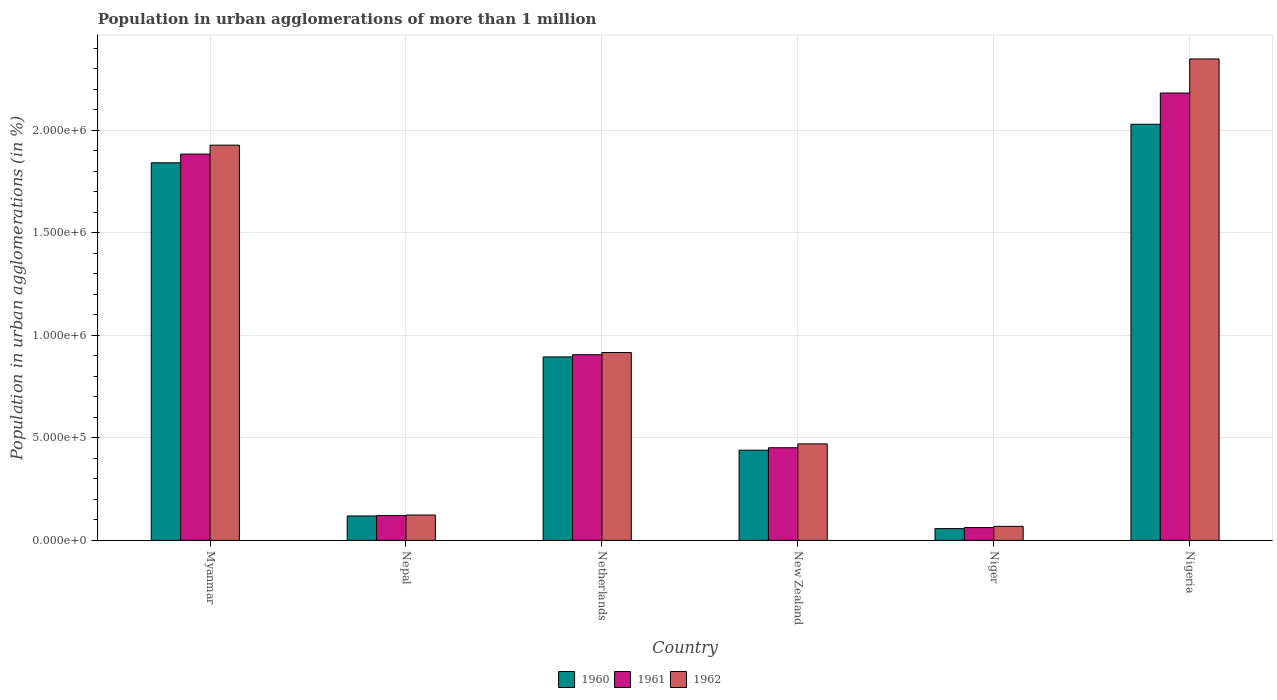How many different coloured bars are there?
Ensure brevity in your answer.  3. How many groups of bars are there?
Your answer should be very brief. 6. Are the number of bars per tick equal to the number of legend labels?
Your answer should be compact. Yes. How many bars are there on the 4th tick from the left?
Ensure brevity in your answer.  3. How many bars are there on the 6th tick from the right?
Offer a very short reply. 3. What is the label of the 6th group of bars from the left?
Provide a short and direct response. Nigeria. What is the population in urban agglomerations in 1961 in Netherlands?
Your answer should be compact. 9.06e+05. Across all countries, what is the maximum population in urban agglomerations in 1962?
Ensure brevity in your answer.  2.35e+06. Across all countries, what is the minimum population in urban agglomerations in 1960?
Give a very brief answer. 5.75e+04. In which country was the population in urban agglomerations in 1962 maximum?
Make the answer very short. Nigeria. In which country was the population in urban agglomerations in 1962 minimum?
Your answer should be compact. Niger. What is the total population in urban agglomerations in 1960 in the graph?
Your answer should be compact. 5.38e+06. What is the difference between the population in urban agglomerations in 1961 in Nepal and that in Niger?
Keep it short and to the point. 5.84e+04. What is the difference between the population in urban agglomerations in 1962 in Nigeria and the population in urban agglomerations in 1961 in Nepal?
Your answer should be very brief. 2.23e+06. What is the average population in urban agglomerations in 1960 per country?
Offer a terse response. 8.97e+05. What is the difference between the population in urban agglomerations of/in 1961 and population in urban agglomerations of/in 1962 in Myanmar?
Your response must be concise. -4.36e+04. What is the ratio of the population in urban agglomerations in 1962 in New Zealand to that in Niger?
Make the answer very short. 6.89. Is the population in urban agglomerations in 1960 in Nepal less than that in Nigeria?
Offer a terse response. Yes. What is the difference between the highest and the second highest population in urban agglomerations in 1962?
Keep it short and to the point. -1.43e+06. What is the difference between the highest and the lowest population in urban agglomerations in 1962?
Your response must be concise. 2.28e+06. How many bars are there?
Offer a very short reply. 18. Are all the bars in the graph horizontal?
Your answer should be very brief. No. Does the graph contain grids?
Ensure brevity in your answer.  Yes. Where does the legend appear in the graph?
Your response must be concise. Bottom center. How many legend labels are there?
Your response must be concise. 3. How are the legend labels stacked?
Make the answer very short. Horizontal. What is the title of the graph?
Ensure brevity in your answer.  Population in urban agglomerations of more than 1 million. Does "1998" appear as one of the legend labels in the graph?
Your answer should be very brief. No. What is the label or title of the Y-axis?
Your answer should be compact. Population in urban agglomerations (in %). What is the Population in urban agglomerations (in %) of 1960 in Myanmar?
Offer a terse response. 1.84e+06. What is the Population in urban agglomerations (in %) of 1961 in Myanmar?
Provide a short and direct response. 1.88e+06. What is the Population in urban agglomerations (in %) of 1962 in Myanmar?
Provide a short and direct response. 1.93e+06. What is the Population in urban agglomerations (in %) of 1960 in Nepal?
Give a very brief answer. 1.19e+05. What is the Population in urban agglomerations (in %) in 1961 in Nepal?
Your answer should be compact. 1.21e+05. What is the Population in urban agglomerations (in %) of 1962 in Nepal?
Offer a terse response. 1.24e+05. What is the Population in urban agglomerations (in %) in 1960 in Netherlands?
Offer a terse response. 8.95e+05. What is the Population in urban agglomerations (in %) of 1961 in Netherlands?
Provide a succinct answer. 9.06e+05. What is the Population in urban agglomerations (in %) in 1962 in Netherlands?
Your answer should be very brief. 9.17e+05. What is the Population in urban agglomerations (in %) in 1960 in New Zealand?
Ensure brevity in your answer.  4.40e+05. What is the Population in urban agglomerations (in %) in 1961 in New Zealand?
Offer a very short reply. 4.52e+05. What is the Population in urban agglomerations (in %) of 1962 in New Zealand?
Provide a succinct answer. 4.71e+05. What is the Population in urban agglomerations (in %) in 1960 in Niger?
Your response must be concise. 5.75e+04. What is the Population in urban agglomerations (in %) in 1961 in Niger?
Provide a succinct answer. 6.27e+04. What is the Population in urban agglomerations (in %) in 1962 in Niger?
Give a very brief answer. 6.83e+04. What is the Population in urban agglomerations (in %) of 1960 in Nigeria?
Your answer should be very brief. 2.03e+06. What is the Population in urban agglomerations (in %) in 1961 in Nigeria?
Your answer should be very brief. 2.18e+06. What is the Population in urban agglomerations (in %) in 1962 in Nigeria?
Your answer should be compact. 2.35e+06. Across all countries, what is the maximum Population in urban agglomerations (in %) of 1960?
Give a very brief answer. 2.03e+06. Across all countries, what is the maximum Population in urban agglomerations (in %) in 1961?
Make the answer very short. 2.18e+06. Across all countries, what is the maximum Population in urban agglomerations (in %) of 1962?
Make the answer very short. 2.35e+06. Across all countries, what is the minimum Population in urban agglomerations (in %) in 1960?
Keep it short and to the point. 5.75e+04. Across all countries, what is the minimum Population in urban agglomerations (in %) in 1961?
Ensure brevity in your answer.  6.27e+04. Across all countries, what is the minimum Population in urban agglomerations (in %) in 1962?
Provide a succinct answer. 6.83e+04. What is the total Population in urban agglomerations (in %) in 1960 in the graph?
Make the answer very short. 5.38e+06. What is the total Population in urban agglomerations (in %) of 1961 in the graph?
Provide a short and direct response. 5.61e+06. What is the total Population in urban agglomerations (in %) in 1962 in the graph?
Provide a short and direct response. 5.86e+06. What is the difference between the Population in urban agglomerations (in %) in 1960 in Myanmar and that in Nepal?
Keep it short and to the point. 1.72e+06. What is the difference between the Population in urban agglomerations (in %) of 1961 in Myanmar and that in Nepal?
Your answer should be compact. 1.76e+06. What is the difference between the Population in urban agglomerations (in %) of 1962 in Myanmar and that in Nepal?
Your answer should be very brief. 1.80e+06. What is the difference between the Population in urban agglomerations (in %) of 1960 in Myanmar and that in Netherlands?
Provide a succinct answer. 9.47e+05. What is the difference between the Population in urban agglomerations (in %) of 1961 in Myanmar and that in Netherlands?
Give a very brief answer. 9.79e+05. What is the difference between the Population in urban agglomerations (in %) in 1962 in Myanmar and that in Netherlands?
Your answer should be compact. 1.01e+06. What is the difference between the Population in urban agglomerations (in %) of 1960 in Myanmar and that in New Zealand?
Offer a very short reply. 1.40e+06. What is the difference between the Population in urban agglomerations (in %) of 1961 in Myanmar and that in New Zealand?
Offer a terse response. 1.43e+06. What is the difference between the Population in urban agglomerations (in %) in 1962 in Myanmar and that in New Zealand?
Give a very brief answer. 1.46e+06. What is the difference between the Population in urban agglomerations (in %) in 1960 in Myanmar and that in Niger?
Provide a succinct answer. 1.78e+06. What is the difference between the Population in urban agglomerations (in %) in 1961 in Myanmar and that in Niger?
Make the answer very short. 1.82e+06. What is the difference between the Population in urban agglomerations (in %) of 1962 in Myanmar and that in Niger?
Your response must be concise. 1.86e+06. What is the difference between the Population in urban agglomerations (in %) of 1960 in Myanmar and that in Nigeria?
Offer a very short reply. -1.88e+05. What is the difference between the Population in urban agglomerations (in %) in 1961 in Myanmar and that in Nigeria?
Provide a short and direct response. -2.98e+05. What is the difference between the Population in urban agglomerations (in %) of 1962 in Myanmar and that in Nigeria?
Your answer should be compact. -4.21e+05. What is the difference between the Population in urban agglomerations (in %) in 1960 in Nepal and that in Netherlands?
Offer a terse response. -7.76e+05. What is the difference between the Population in urban agglomerations (in %) in 1961 in Nepal and that in Netherlands?
Make the answer very short. -7.85e+05. What is the difference between the Population in urban agglomerations (in %) of 1962 in Nepal and that in Netherlands?
Make the answer very short. -7.93e+05. What is the difference between the Population in urban agglomerations (in %) of 1960 in Nepal and that in New Zealand?
Ensure brevity in your answer.  -3.21e+05. What is the difference between the Population in urban agglomerations (in %) in 1961 in Nepal and that in New Zealand?
Your answer should be compact. -3.31e+05. What is the difference between the Population in urban agglomerations (in %) in 1962 in Nepal and that in New Zealand?
Provide a succinct answer. -3.47e+05. What is the difference between the Population in urban agglomerations (in %) of 1960 in Nepal and that in Niger?
Make the answer very short. 6.16e+04. What is the difference between the Population in urban agglomerations (in %) in 1961 in Nepal and that in Niger?
Give a very brief answer. 5.84e+04. What is the difference between the Population in urban agglomerations (in %) of 1962 in Nepal and that in Niger?
Offer a very short reply. 5.54e+04. What is the difference between the Population in urban agglomerations (in %) in 1960 in Nepal and that in Nigeria?
Give a very brief answer. -1.91e+06. What is the difference between the Population in urban agglomerations (in %) of 1961 in Nepal and that in Nigeria?
Provide a short and direct response. -2.06e+06. What is the difference between the Population in urban agglomerations (in %) of 1962 in Nepal and that in Nigeria?
Provide a succinct answer. -2.23e+06. What is the difference between the Population in urban agglomerations (in %) of 1960 in Netherlands and that in New Zealand?
Offer a terse response. 4.55e+05. What is the difference between the Population in urban agglomerations (in %) of 1961 in Netherlands and that in New Zealand?
Give a very brief answer. 4.54e+05. What is the difference between the Population in urban agglomerations (in %) of 1962 in Netherlands and that in New Zealand?
Provide a short and direct response. 4.46e+05. What is the difference between the Population in urban agglomerations (in %) of 1960 in Netherlands and that in Niger?
Make the answer very short. 8.38e+05. What is the difference between the Population in urban agglomerations (in %) in 1961 in Netherlands and that in Niger?
Your response must be concise. 8.43e+05. What is the difference between the Population in urban agglomerations (in %) in 1962 in Netherlands and that in Niger?
Ensure brevity in your answer.  8.48e+05. What is the difference between the Population in urban agglomerations (in %) of 1960 in Netherlands and that in Nigeria?
Offer a terse response. -1.14e+06. What is the difference between the Population in urban agglomerations (in %) of 1961 in Netherlands and that in Nigeria?
Ensure brevity in your answer.  -1.28e+06. What is the difference between the Population in urban agglomerations (in %) of 1962 in Netherlands and that in Nigeria?
Your answer should be compact. -1.43e+06. What is the difference between the Population in urban agglomerations (in %) of 1960 in New Zealand and that in Niger?
Your answer should be very brief. 3.83e+05. What is the difference between the Population in urban agglomerations (in %) in 1961 in New Zealand and that in Niger?
Keep it short and to the point. 3.89e+05. What is the difference between the Population in urban agglomerations (in %) of 1962 in New Zealand and that in Niger?
Provide a short and direct response. 4.03e+05. What is the difference between the Population in urban agglomerations (in %) in 1960 in New Zealand and that in Nigeria?
Your answer should be very brief. -1.59e+06. What is the difference between the Population in urban agglomerations (in %) in 1961 in New Zealand and that in Nigeria?
Provide a succinct answer. -1.73e+06. What is the difference between the Population in urban agglomerations (in %) of 1962 in New Zealand and that in Nigeria?
Provide a succinct answer. -1.88e+06. What is the difference between the Population in urban agglomerations (in %) in 1960 in Niger and that in Nigeria?
Provide a short and direct response. -1.97e+06. What is the difference between the Population in urban agglomerations (in %) of 1961 in Niger and that in Nigeria?
Your answer should be very brief. -2.12e+06. What is the difference between the Population in urban agglomerations (in %) of 1962 in Niger and that in Nigeria?
Your response must be concise. -2.28e+06. What is the difference between the Population in urban agglomerations (in %) in 1960 in Myanmar and the Population in urban agglomerations (in %) in 1961 in Nepal?
Make the answer very short. 1.72e+06. What is the difference between the Population in urban agglomerations (in %) of 1960 in Myanmar and the Population in urban agglomerations (in %) of 1962 in Nepal?
Offer a very short reply. 1.72e+06. What is the difference between the Population in urban agglomerations (in %) of 1961 in Myanmar and the Population in urban agglomerations (in %) of 1962 in Nepal?
Ensure brevity in your answer.  1.76e+06. What is the difference between the Population in urban agglomerations (in %) in 1960 in Myanmar and the Population in urban agglomerations (in %) in 1961 in Netherlands?
Give a very brief answer. 9.36e+05. What is the difference between the Population in urban agglomerations (in %) in 1960 in Myanmar and the Population in urban agglomerations (in %) in 1962 in Netherlands?
Provide a succinct answer. 9.26e+05. What is the difference between the Population in urban agglomerations (in %) of 1961 in Myanmar and the Population in urban agglomerations (in %) of 1962 in Netherlands?
Give a very brief answer. 9.68e+05. What is the difference between the Population in urban agglomerations (in %) of 1960 in Myanmar and the Population in urban agglomerations (in %) of 1961 in New Zealand?
Provide a succinct answer. 1.39e+06. What is the difference between the Population in urban agglomerations (in %) of 1960 in Myanmar and the Population in urban agglomerations (in %) of 1962 in New Zealand?
Your answer should be very brief. 1.37e+06. What is the difference between the Population in urban agglomerations (in %) of 1961 in Myanmar and the Population in urban agglomerations (in %) of 1962 in New Zealand?
Make the answer very short. 1.41e+06. What is the difference between the Population in urban agglomerations (in %) in 1960 in Myanmar and the Population in urban agglomerations (in %) in 1961 in Niger?
Offer a very short reply. 1.78e+06. What is the difference between the Population in urban agglomerations (in %) of 1960 in Myanmar and the Population in urban agglomerations (in %) of 1962 in Niger?
Offer a very short reply. 1.77e+06. What is the difference between the Population in urban agglomerations (in %) of 1961 in Myanmar and the Population in urban agglomerations (in %) of 1962 in Niger?
Make the answer very short. 1.82e+06. What is the difference between the Population in urban agglomerations (in %) of 1960 in Myanmar and the Population in urban agglomerations (in %) of 1961 in Nigeria?
Provide a short and direct response. -3.40e+05. What is the difference between the Population in urban agglomerations (in %) of 1960 in Myanmar and the Population in urban agglomerations (in %) of 1962 in Nigeria?
Your answer should be compact. -5.07e+05. What is the difference between the Population in urban agglomerations (in %) in 1961 in Myanmar and the Population in urban agglomerations (in %) in 1962 in Nigeria?
Offer a very short reply. -4.64e+05. What is the difference between the Population in urban agglomerations (in %) in 1960 in Nepal and the Population in urban agglomerations (in %) in 1961 in Netherlands?
Give a very brief answer. -7.87e+05. What is the difference between the Population in urban agglomerations (in %) in 1960 in Nepal and the Population in urban agglomerations (in %) in 1962 in Netherlands?
Offer a very short reply. -7.98e+05. What is the difference between the Population in urban agglomerations (in %) in 1961 in Nepal and the Population in urban agglomerations (in %) in 1962 in Netherlands?
Keep it short and to the point. -7.96e+05. What is the difference between the Population in urban agglomerations (in %) of 1960 in Nepal and the Population in urban agglomerations (in %) of 1961 in New Zealand?
Keep it short and to the point. -3.33e+05. What is the difference between the Population in urban agglomerations (in %) of 1960 in Nepal and the Population in urban agglomerations (in %) of 1962 in New Zealand?
Keep it short and to the point. -3.52e+05. What is the difference between the Population in urban agglomerations (in %) in 1961 in Nepal and the Population in urban agglomerations (in %) in 1962 in New Zealand?
Your response must be concise. -3.50e+05. What is the difference between the Population in urban agglomerations (in %) of 1960 in Nepal and the Population in urban agglomerations (in %) of 1961 in Niger?
Your response must be concise. 5.65e+04. What is the difference between the Population in urban agglomerations (in %) in 1960 in Nepal and the Population in urban agglomerations (in %) in 1962 in Niger?
Your answer should be compact. 5.08e+04. What is the difference between the Population in urban agglomerations (in %) in 1961 in Nepal and the Population in urban agglomerations (in %) in 1962 in Niger?
Give a very brief answer. 5.28e+04. What is the difference between the Population in urban agglomerations (in %) in 1960 in Nepal and the Population in urban agglomerations (in %) in 1961 in Nigeria?
Give a very brief answer. -2.06e+06. What is the difference between the Population in urban agglomerations (in %) in 1960 in Nepal and the Population in urban agglomerations (in %) in 1962 in Nigeria?
Your response must be concise. -2.23e+06. What is the difference between the Population in urban agglomerations (in %) of 1961 in Nepal and the Population in urban agglomerations (in %) of 1962 in Nigeria?
Your answer should be very brief. -2.23e+06. What is the difference between the Population in urban agglomerations (in %) in 1960 in Netherlands and the Population in urban agglomerations (in %) in 1961 in New Zealand?
Keep it short and to the point. 4.43e+05. What is the difference between the Population in urban agglomerations (in %) of 1960 in Netherlands and the Population in urban agglomerations (in %) of 1962 in New Zealand?
Your response must be concise. 4.24e+05. What is the difference between the Population in urban agglomerations (in %) in 1961 in Netherlands and the Population in urban agglomerations (in %) in 1962 in New Zealand?
Provide a succinct answer. 4.35e+05. What is the difference between the Population in urban agglomerations (in %) of 1960 in Netherlands and the Population in urban agglomerations (in %) of 1961 in Niger?
Offer a very short reply. 8.33e+05. What is the difference between the Population in urban agglomerations (in %) in 1960 in Netherlands and the Population in urban agglomerations (in %) in 1962 in Niger?
Offer a terse response. 8.27e+05. What is the difference between the Population in urban agglomerations (in %) of 1961 in Netherlands and the Population in urban agglomerations (in %) of 1962 in Niger?
Provide a short and direct response. 8.38e+05. What is the difference between the Population in urban agglomerations (in %) in 1960 in Netherlands and the Population in urban agglomerations (in %) in 1961 in Nigeria?
Give a very brief answer. -1.29e+06. What is the difference between the Population in urban agglomerations (in %) in 1960 in Netherlands and the Population in urban agglomerations (in %) in 1962 in Nigeria?
Ensure brevity in your answer.  -1.45e+06. What is the difference between the Population in urban agglomerations (in %) of 1961 in Netherlands and the Population in urban agglomerations (in %) of 1962 in Nigeria?
Your answer should be very brief. -1.44e+06. What is the difference between the Population in urban agglomerations (in %) in 1960 in New Zealand and the Population in urban agglomerations (in %) in 1961 in Niger?
Offer a very short reply. 3.77e+05. What is the difference between the Population in urban agglomerations (in %) of 1960 in New Zealand and the Population in urban agglomerations (in %) of 1962 in Niger?
Provide a short and direct response. 3.72e+05. What is the difference between the Population in urban agglomerations (in %) of 1961 in New Zealand and the Population in urban agglomerations (in %) of 1962 in Niger?
Offer a terse response. 3.84e+05. What is the difference between the Population in urban agglomerations (in %) in 1960 in New Zealand and the Population in urban agglomerations (in %) in 1961 in Nigeria?
Provide a succinct answer. -1.74e+06. What is the difference between the Population in urban agglomerations (in %) in 1960 in New Zealand and the Population in urban agglomerations (in %) in 1962 in Nigeria?
Provide a short and direct response. -1.91e+06. What is the difference between the Population in urban agglomerations (in %) of 1961 in New Zealand and the Population in urban agglomerations (in %) of 1962 in Nigeria?
Your answer should be compact. -1.90e+06. What is the difference between the Population in urban agglomerations (in %) of 1960 in Niger and the Population in urban agglomerations (in %) of 1961 in Nigeria?
Offer a very short reply. -2.13e+06. What is the difference between the Population in urban agglomerations (in %) in 1960 in Niger and the Population in urban agglomerations (in %) in 1962 in Nigeria?
Offer a very short reply. -2.29e+06. What is the difference between the Population in urban agglomerations (in %) of 1961 in Niger and the Population in urban agglomerations (in %) of 1962 in Nigeria?
Offer a very short reply. -2.29e+06. What is the average Population in urban agglomerations (in %) of 1960 per country?
Offer a very short reply. 8.97e+05. What is the average Population in urban agglomerations (in %) in 1961 per country?
Offer a very short reply. 9.35e+05. What is the average Population in urban agglomerations (in %) of 1962 per country?
Give a very brief answer. 9.76e+05. What is the difference between the Population in urban agglomerations (in %) in 1960 and Population in urban agglomerations (in %) in 1961 in Myanmar?
Provide a short and direct response. -4.25e+04. What is the difference between the Population in urban agglomerations (in %) in 1960 and Population in urban agglomerations (in %) in 1962 in Myanmar?
Provide a short and direct response. -8.61e+04. What is the difference between the Population in urban agglomerations (in %) of 1961 and Population in urban agglomerations (in %) of 1962 in Myanmar?
Offer a very short reply. -4.36e+04. What is the difference between the Population in urban agglomerations (in %) in 1960 and Population in urban agglomerations (in %) in 1961 in Nepal?
Provide a succinct answer. -1907. What is the difference between the Population in urban agglomerations (in %) of 1960 and Population in urban agglomerations (in %) of 1962 in Nepal?
Provide a succinct answer. -4568. What is the difference between the Population in urban agglomerations (in %) in 1961 and Population in urban agglomerations (in %) in 1962 in Nepal?
Give a very brief answer. -2661. What is the difference between the Population in urban agglomerations (in %) in 1960 and Population in urban agglomerations (in %) in 1961 in Netherlands?
Give a very brief answer. -1.07e+04. What is the difference between the Population in urban agglomerations (in %) of 1960 and Population in urban agglomerations (in %) of 1962 in Netherlands?
Keep it short and to the point. -2.15e+04. What is the difference between the Population in urban agglomerations (in %) of 1961 and Population in urban agglomerations (in %) of 1962 in Netherlands?
Your response must be concise. -1.08e+04. What is the difference between the Population in urban agglomerations (in %) in 1960 and Population in urban agglomerations (in %) in 1961 in New Zealand?
Keep it short and to the point. -1.19e+04. What is the difference between the Population in urban agglomerations (in %) of 1960 and Population in urban agglomerations (in %) of 1962 in New Zealand?
Your answer should be compact. -3.07e+04. What is the difference between the Population in urban agglomerations (in %) of 1961 and Population in urban agglomerations (in %) of 1962 in New Zealand?
Provide a succinct answer. -1.88e+04. What is the difference between the Population in urban agglomerations (in %) of 1960 and Population in urban agglomerations (in %) of 1961 in Niger?
Make the answer very short. -5156. What is the difference between the Population in urban agglomerations (in %) in 1960 and Population in urban agglomerations (in %) in 1962 in Niger?
Give a very brief answer. -1.08e+04. What is the difference between the Population in urban agglomerations (in %) in 1961 and Population in urban agglomerations (in %) in 1962 in Niger?
Give a very brief answer. -5625. What is the difference between the Population in urban agglomerations (in %) of 1960 and Population in urban agglomerations (in %) of 1961 in Nigeria?
Keep it short and to the point. -1.52e+05. What is the difference between the Population in urban agglomerations (in %) in 1960 and Population in urban agglomerations (in %) in 1962 in Nigeria?
Your answer should be compact. -3.19e+05. What is the difference between the Population in urban agglomerations (in %) in 1961 and Population in urban agglomerations (in %) in 1962 in Nigeria?
Your answer should be compact. -1.66e+05. What is the ratio of the Population in urban agglomerations (in %) in 1960 in Myanmar to that in Nepal?
Provide a succinct answer. 15.46. What is the ratio of the Population in urban agglomerations (in %) of 1961 in Myanmar to that in Nepal?
Give a very brief answer. 15.57. What is the ratio of the Population in urban agglomerations (in %) of 1962 in Myanmar to that in Nepal?
Offer a very short reply. 15.58. What is the ratio of the Population in urban agglomerations (in %) of 1960 in Myanmar to that in Netherlands?
Your answer should be very brief. 2.06. What is the ratio of the Population in urban agglomerations (in %) of 1961 in Myanmar to that in Netherlands?
Provide a succinct answer. 2.08. What is the ratio of the Population in urban agglomerations (in %) of 1962 in Myanmar to that in Netherlands?
Your answer should be very brief. 2.1. What is the ratio of the Population in urban agglomerations (in %) in 1960 in Myanmar to that in New Zealand?
Offer a terse response. 4.19. What is the ratio of the Population in urban agglomerations (in %) in 1961 in Myanmar to that in New Zealand?
Keep it short and to the point. 4.17. What is the ratio of the Population in urban agglomerations (in %) in 1962 in Myanmar to that in New Zealand?
Keep it short and to the point. 4.1. What is the ratio of the Population in urban agglomerations (in %) of 1960 in Myanmar to that in Niger?
Your answer should be very brief. 32.01. What is the ratio of the Population in urban agglomerations (in %) in 1961 in Myanmar to that in Niger?
Your response must be concise. 30.06. What is the ratio of the Population in urban agglomerations (in %) of 1962 in Myanmar to that in Niger?
Make the answer very short. 28.22. What is the ratio of the Population in urban agglomerations (in %) in 1960 in Myanmar to that in Nigeria?
Offer a very short reply. 0.91. What is the ratio of the Population in urban agglomerations (in %) of 1961 in Myanmar to that in Nigeria?
Provide a succinct answer. 0.86. What is the ratio of the Population in urban agglomerations (in %) in 1962 in Myanmar to that in Nigeria?
Give a very brief answer. 0.82. What is the ratio of the Population in urban agglomerations (in %) in 1960 in Nepal to that in Netherlands?
Offer a terse response. 0.13. What is the ratio of the Population in urban agglomerations (in %) of 1961 in Nepal to that in Netherlands?
Your answer should be compact. 0.13. What is the ratio of the Population in urban agglomerations (in %) of 1962 in Nepal to that in Netherlands?
Ensure brevity in your answer.  0.14. What is the ratio of the Population in urban agglomerations (in %) in 1960 in Nepal to that in New Zealand?
Offer a very short reply. 0.27. What is the ratio of the Population in urban agglomerations (in %) in 1961 in Nepal to that in New Zealand?
Your answer should be very brief. 0.27. What is the ratio of the Population in urban agglomerations (in %) of 1962 in Nepal to that in New Zealand?
Offer a terse response. 0.26. What is the ratio of the Population in urban agglomerations (in %) of 1960 in Nepal to that in Niger?
Provide a succinct answer. 2.07. What is the ratio of the Population in urban agglomerations (in %) of 1961 in Nepal to that in Niger?
Keep it short and to the point. 1.93. What is the ratio of the Population in urban agglomerations (in %) of 1962 in Nepal to that in Niger?
Keep it short and to the point. 1.81. What is the ratio of the Population in urban agglomerations (in %) in 1960 in Nepal to that in Nigeria?
Provide a succinct answer. 0.06. What is the ratio of the Population in urban agglomerations (in %) in 1961 in Nepal to that in Nigeria?
Give a very brief answer. 0.06. What is the ratio of the Population in urban agglomerations (in %) in 1962 in Nepal to that in Nigeria?
Your answer should be very brief. 0.05. What is the ratio of the Population in urban agglomerations (in %) in 1960 in Netherlands to that in New Zealand?
Offer a terse response. 2.03. What is the ratio of the Population in urban agglomerations (in %) of 1961 in Netherlands to that in New Zealand?
Your answer should be very brief. 2. What is the ratio of the Population in urban agglomerations (in %) of 1962 in Netherlands to that in New Zealand?
Offer a terse response. 1.95. What is the ratio of the Population in urban agglomerations (in %) in 1960 in Netherlands to that in Niger?
Your response must be concise. 15.56. What is the ratio of the Population in urban agglomerations (in %) of 1961 in Netherlands to that in Niger?
Your answer should be very brief. 14.45. What is the ratio of the Population in urban agglomerations (in %) in 1962 in Netherlands to that in Niger?
Offer a terse response. 13.42. What is the ratio of the Population in urban agglomerations (in %) of 1960 in Netherlands to that in Nigeria?
Your answer should be very brief. 0.44. What is the ratio of the Population in urban agglomerations (in %) in 1961 in Netherlands to that in Nigeria?
Provide a succinct answer. 0.41. What is the ratio of the Population in urban agglomerations (in %) of 1962 in Netherlands to that in Nigeria?
Provide a succinct answer. 0.39. What is the ratio of the Population in urban agglomerations (in %) of 1960 in New Zealand to that in Niger?
Give a very brief answer. 7.65. What is the ratio of the Population in urban agglomerations (in %) of 1961 in New Zealand to that in Niger?
Give a very brief answer. 7.21. What is the ratio of the Population in urban agglomerations (in %) of 1962 in New Zealand to that in Niger?
Ensure brevity in your answer.  6.89. What is the ratio of the Population in urban agglomerations (in %) in 1960 in New Zealand to that in Nigeria?
Provide a succinct answer. 0.22. What is the ratio of the Population in urban agglomerations (in %) in 1961 in New Zealand to that in Nigeria?
Provide a succinct answer. 0.21. What is the ratio of the Population in urban agglomerations (in %) in 1962 in New Zealand to that in Nigeria?
Offer a terse response. 0.2. What is the ratio of the Population in urban agglomerations (in %) of 1960 in Niger to that in Nigeria?
Ensure brevity in your answer.  0.03. What is the ratio of the Population in urban agglomerations (in %) of 1961 in Niger to that in Nigeria?
Provide a short and direct response. 0.03. What is the ratio of the Population in urban agglomerations (in %) in 1962 in Niger to that in Nigeria?
Give a very brief answer. 0.03. What is the difference between the highest and the second highest Population in urban agglomerations (in %) of 1960?
Keep it short and to the point. 1.88e+05. What is the difference between the highest and the second highest Population in urban agglomerations (in %) in 1961?
Your answer should be very brief. 2.98e+05. What is the difference between the highest and the second highest Population in urban agglomerations (in %) in 1962?
Provide a short and direct response. 4.21e+05. What is the difference between the highest and the lowest Population in urban agglomerations (in %) in 1960?
Offer a terse response. 1.97e+06. What is the difference between the highest and the lowest Population in urban agglomerations (in %) of 1961?
Ensure brevity in your answer.  2.12e+06. What is the difference between the highest and the lowest Population in urban agglomerations (in %) in 1962?
Provide a succinct answer. 2.28e+06. 